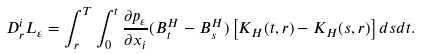<formula> <loc_0><loc_0><loc_500><loc_500>D _ { r } ^ { i } L _ { \varepsilon } = \int _ { r } ^ { T } \int _ { 0 } ^ { t } \frac { \partial p _ { \varepsilon } } { \partial x _ { i } } ( B _ { t } ^ { H } - B _ { s } ^ { H } ) \left [ K _ { H } ( t , r ) - K _ { H } ( s , r ) \right ] d s d t .</formula> 